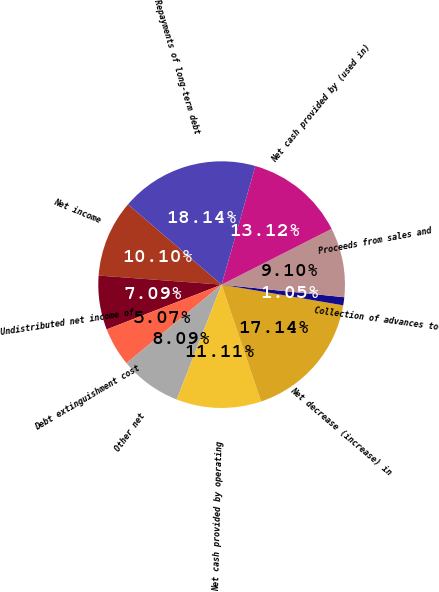Convert chart. <chart><loc_0><loc_0><loc_500><loc_500><pie_chart><fcel>Net income<fcel>Undistributed net income of<fcel>Debt extinguishment cost<fcel>Other net<fcel>Net cash provided by operating<fcel>Net decrease (increase) in<fcel>Collection of advances to<fcel>Proceeds from sales and<fcel>Net cash provided by (used in)<fcel>Repayments of long-term debt<nl><fcel>10.1%<fcel>7.09%<fcel>5.07%<fcel>8.09%<fcel>11.11%<fcel>17.14%<fcel>1.05%<fcel>9.1%<fcel>13.12%<fcel>18.14%<nl></chart> 